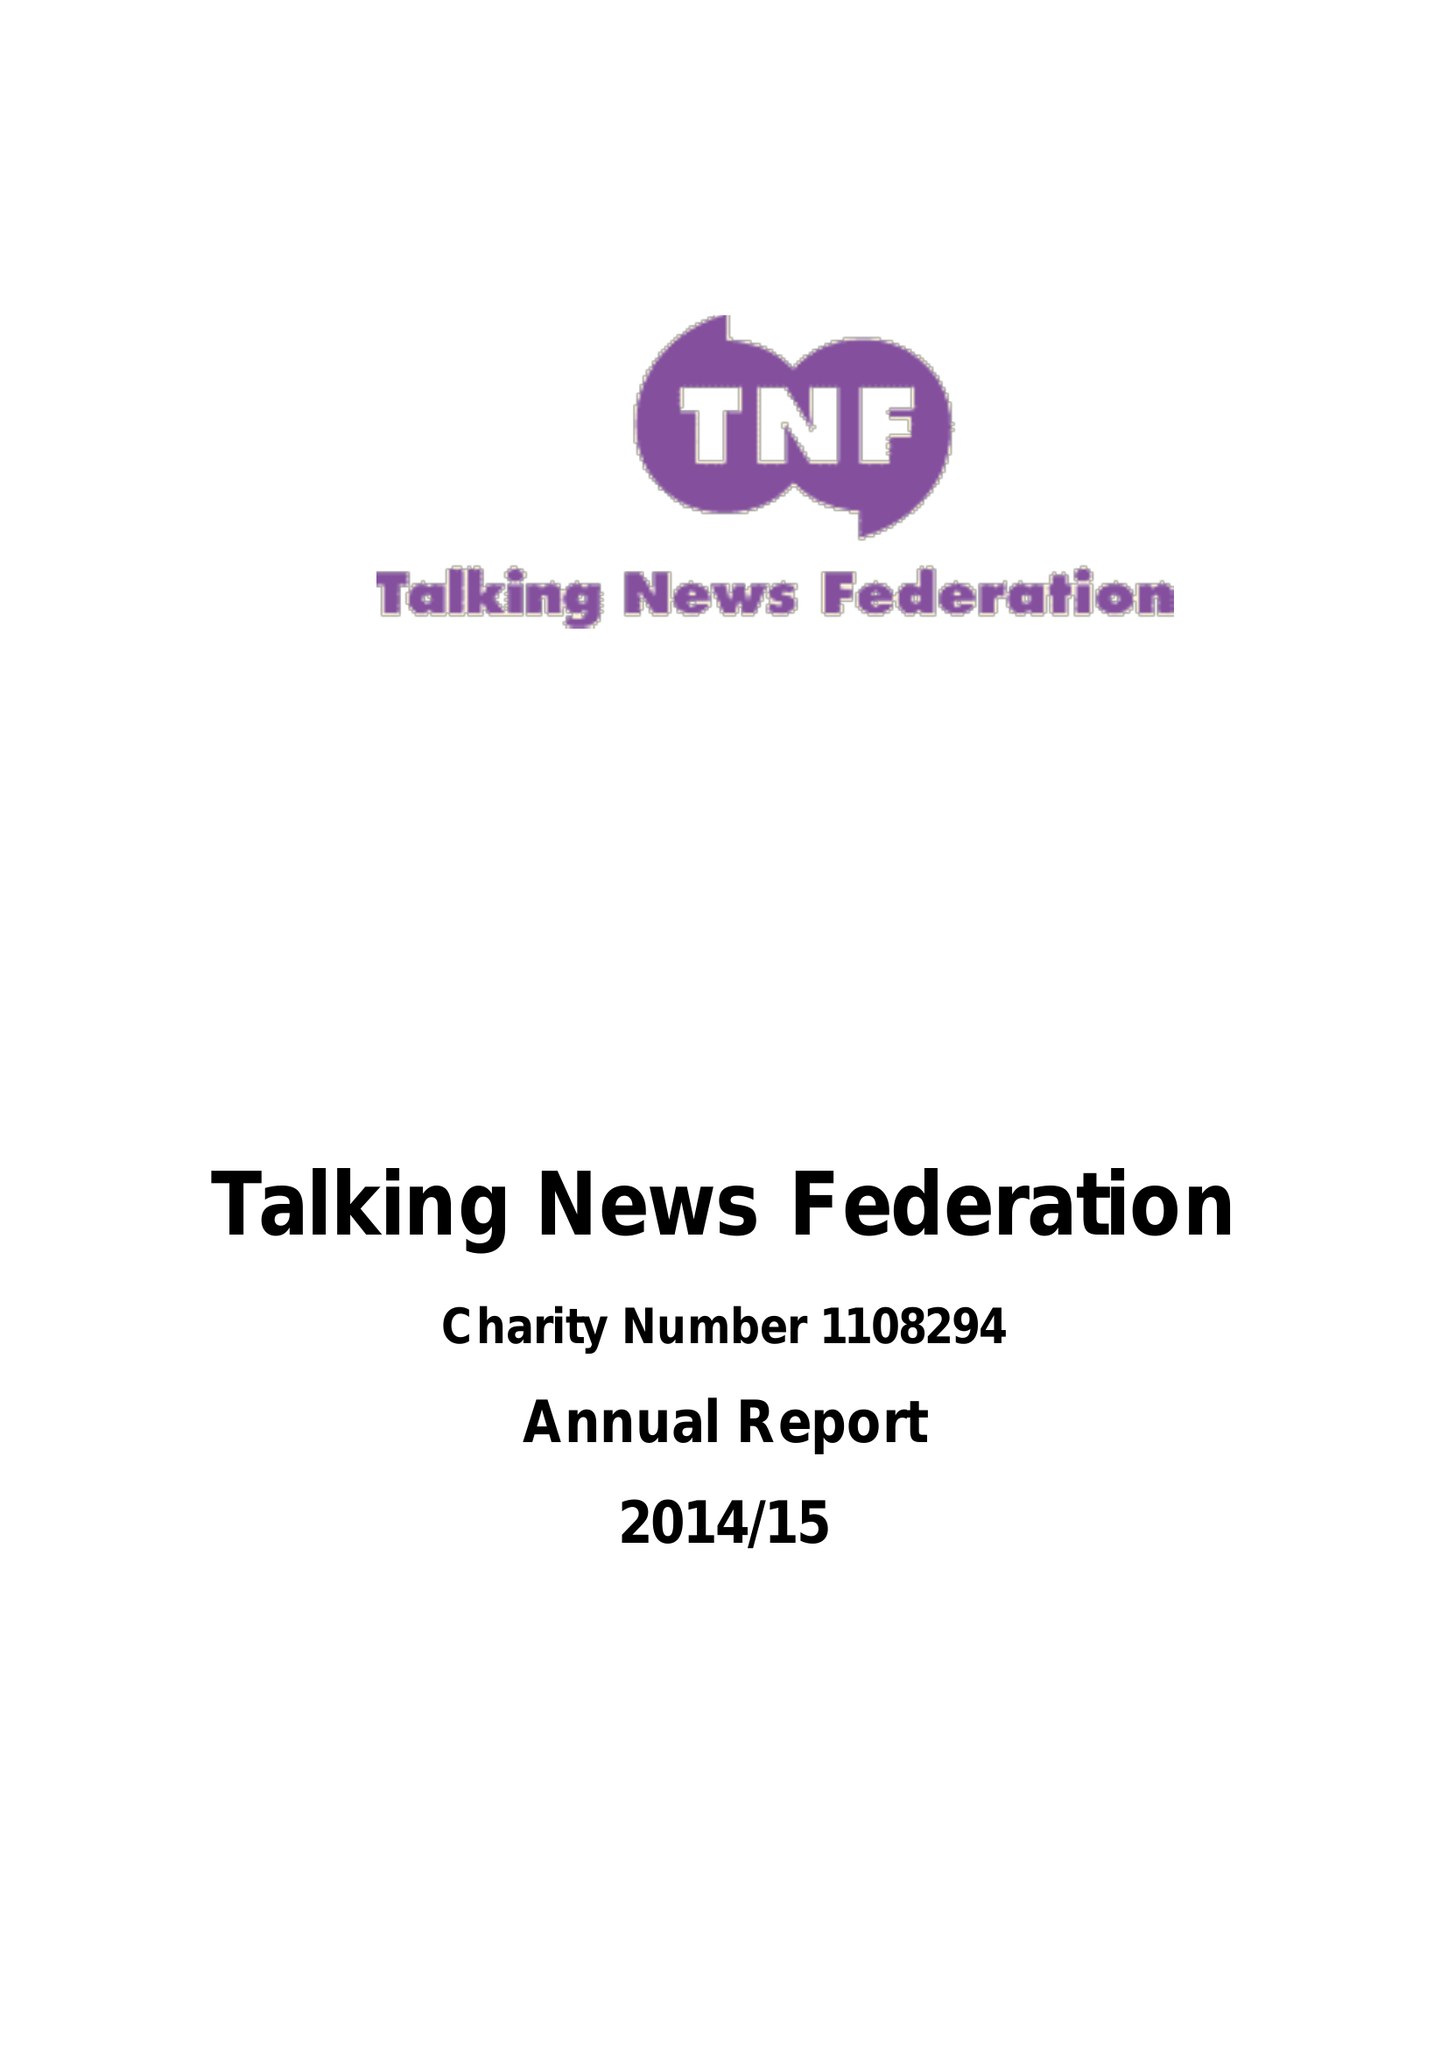What is the value for the report_date?
Answer the question using a single word or phrase. 2015-03-31 